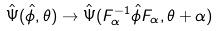Convert formula to latex. <formula><loc_0><loc_0><loc_500><loc_500>\hat { \Psi } ( \hat { \phi } , \theta ) \rightarrow \hat { \Psi } ( F _ { \alpha } ^ { - 1 } \hat { \phi } F _ { \alpha } , \theta + \alpha )</formula> 